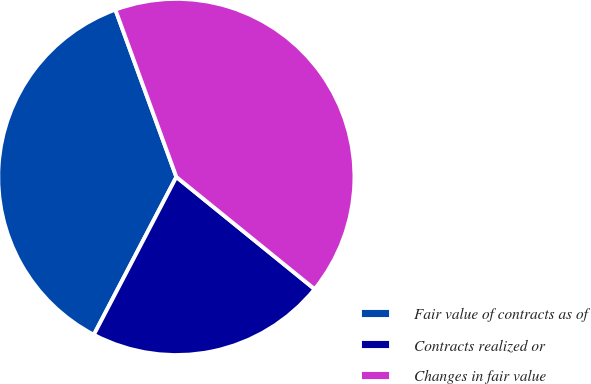Convert chart. <chart><loc_0><loc_0><loc_500><loc_500><pie_chart><fcel>Fair value of contracts as of<fcel>Contracts realized or<fcel>Changes in fair value<nl><fcel>36.77%<fcel>21.82%<fcel>41.41%<nl></chart> 